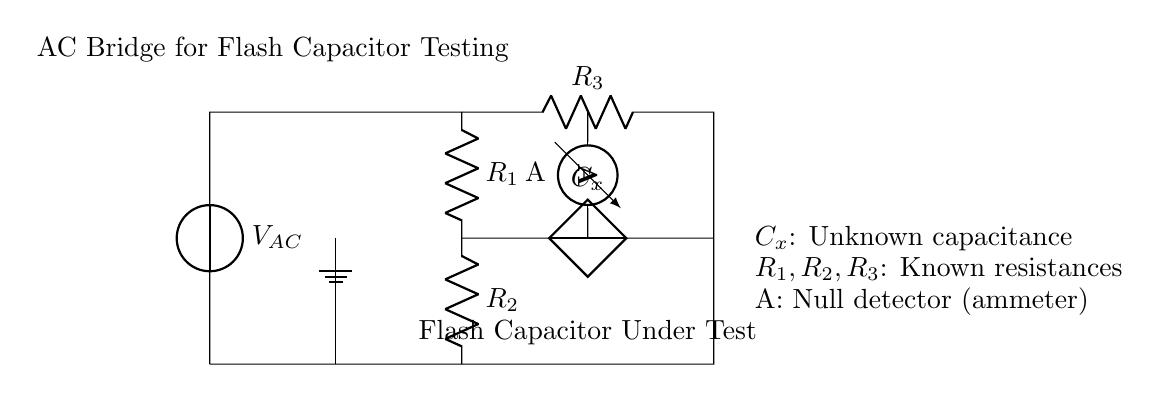What type of source is used in this circuit? The diagram indicates a voltage source labeled as V_AC, which means it provides alternating current (AC) voltage.
Answer: voltage source What is represented by the symbol labeled C_x? The symbol C_x represents an unknown capacitance that is being tested in the circuit, specifically the flash capacitor under test.
Answer: unknown capacitance Which component is used as a null detector in this circuit? The circuit includes an ammeter labeled as A, which measures the current and acts as a null detector to indicate balance in the bridge circuit.
Answer: ammeter What type of circuit is this? This circuit is classified as an AC bridge circuit, specifically designed for testing and matching flash capacitors in studio lighting.
Answer: AC bridge circuit What are the resistances labeled in the circuit? The resistances labeled in the circuit are R_1, R_2, and R_3, which are known values used to balance the bridge and determine the capacitance.
Answer: R_1, R_2, R_3 What is the primary role of the ammeter in this circuit? The ammeter is used to detect current flow; in a balanced bridge circuit, the current through it will be zero, indicating a match between known and unknown components.
Answer: detect current How is the flash capacitor tested in this bridge setup? The flash capacitor is tested by adjusting the known resistances until the ammeter reads zero current, indicating the bridge is balanced and the capacitance matches the calculated value based on resistances.
Answer: by balancing the bridge 